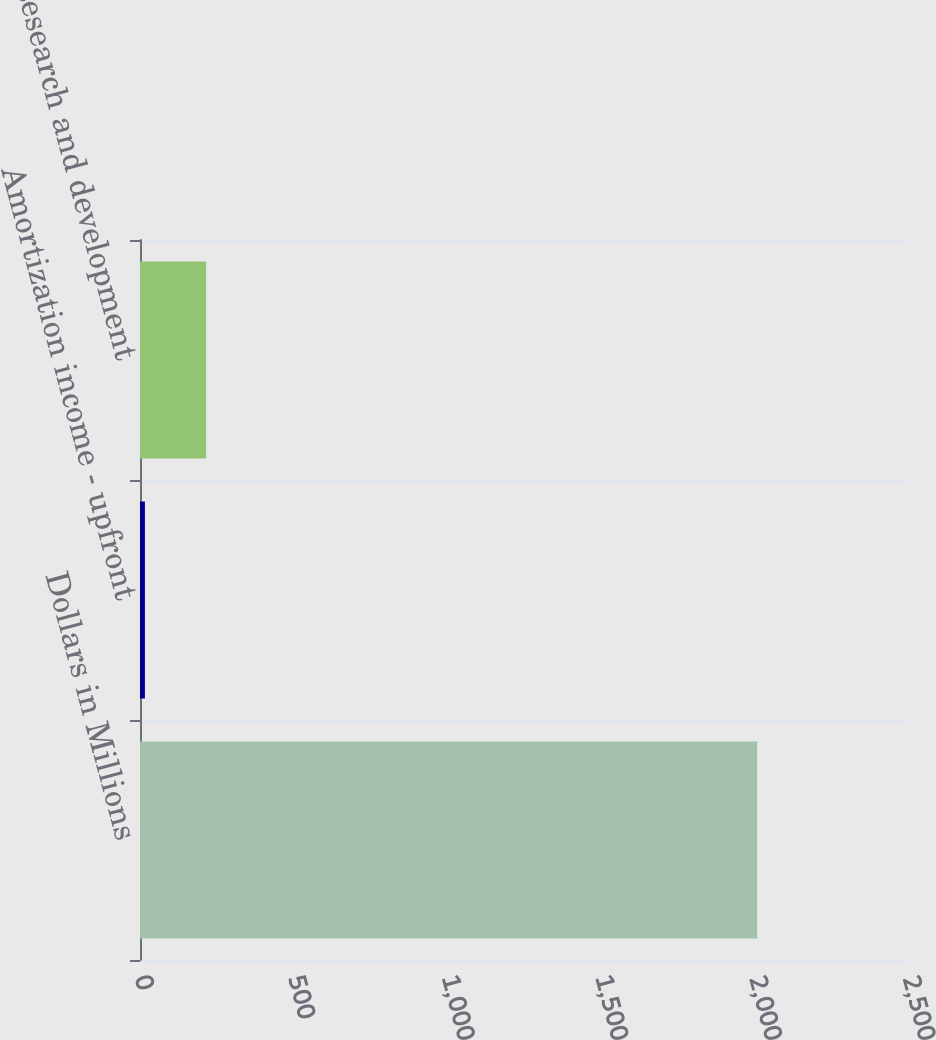Convert chart. <chart><loc_0><loc_0><loc_500><loc_500><bar_chart><fcel>Dollars in Millions<fcel>Amortization income - upfront<fcel>Research and development<nl><fcel>2009<fcel>16<fcel>215.3<nl></chart> 